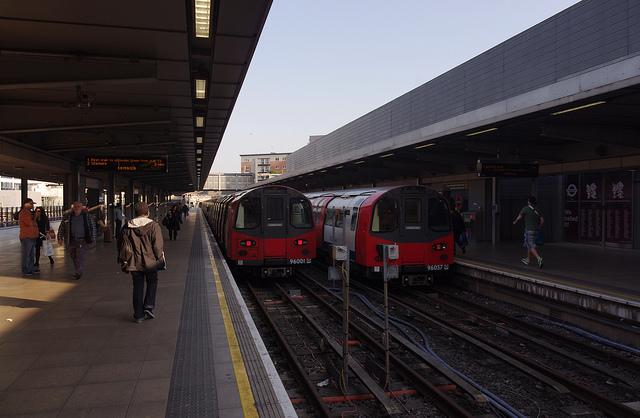What information does such an electronic billboard depict in this scenario? Please explain your reasoning. train. It gives route and times for the next arrivals 